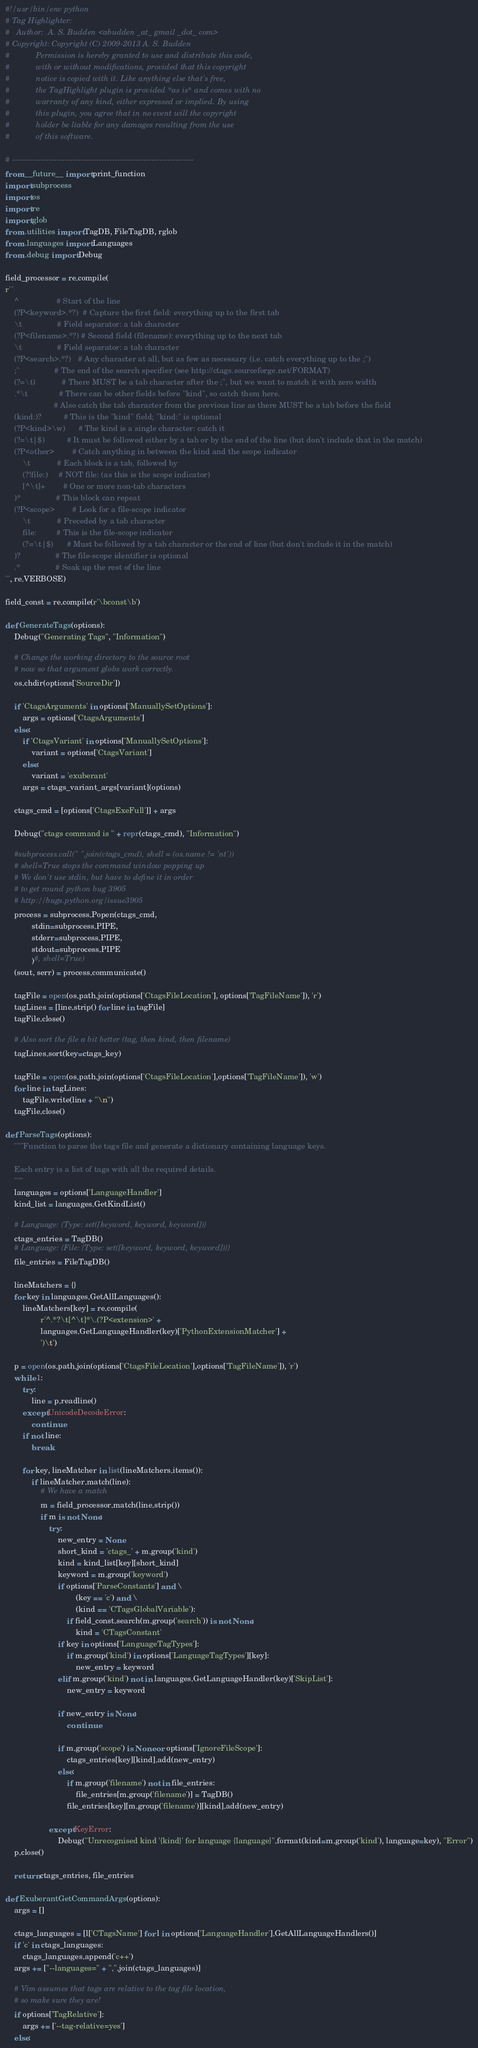<code> <loc_0><loc_0><loc_500><loc_500><_Python_>#!/usr/bin/env python
# Tag Highlighter:
#   Author:  A. S. Budden <abudden _at_ gmail _dot_ com>
# Copyright: Copyright (C) 2009-2013 A. S. Budden
#            Permission is hereby granted to use and distribute this code,
#            with or without modifications, provided that this copyright
#            notice is copied with it. Like anything else that's free,
#            the TagHighlight plugin is provided *as is* and comes with no
#            warranty of any kind, either expressed or implied. By using
#            this plugin, you agree that in no event will the copyright
#            holder be liable for any damages resulting from the use
#            of this software.

# ---------------------------------------------------------------------
from __future__ import print_function
import subprocess
import os
import re
import glob
from .utilities import TagDB, FileTagDB, rglob
from .languages import Languages
from .debug import Debug

field_processor = re.compile(
r'''
    ^                 # Start of the line
    (?P<keyword>.*?)  # Capture the first field: everything up to the first tab
    \t                # Field separator: a tab character
    (?P<filename>.*?) # Second field (filename): everything up to the next tab
    \t                # Field separator: a tab character
    (?P<search>.*?)   # Any character at all, but as few as necessary (i.e. catch everything up to the ;")
    ;"                # The end of the search specifier (see http://ctags.sourceforge.net/FORMAT)
    (?=\t)            # There MUST be a tab character after the ;", but we want to match it with zero width
    .*\t              # There can be other fields before "kind", so catch them here.
                      # Also catch the tab character from the previous line as there MUST be a tab before the field
    (kind:)?          # This is the "kind" field; "kind:" is optional
    (?P<kind>\w)      # The kind is a single character: catch it
    (?=\t|$)          # It must be followed either by a tab or by the end of the line (but don't include that in the match)
    (?P<other>        # Catch anything in between the kind and the scope indicator
        \t            # Each block is a tab, followed by
        (?!file:)     # NOT file: (as this is the scope indicator)
        [^\t]+        # One or more non-tab characters
    )*                # This block can repeat
    (?P<scope>        # Look for a file-scope indicator
        \t            # Preceded by a tab character
        file:         # This is the file-scope indicator
        (?=\t|$)      # Must be followed by a tab character or the end of line (but don't include it in the match)
    )?                # The file-scope identifier is optional
    .*                # Soak up the rest of the line
''', re.VERBOSE)

field_const = re.compile(r'\bconst\b')

def GenerateTags(options):
    Debug("Generating Tags", "Information")

    # Change the working directory to the source root
    # now so that argument globs work correctly.
    os.chdir(options['SourceDir'])

    if 'CtagsArguments' in options['ManuallySetOptions']:
        args = options['CtagsArguments']
    else:
        if 'CtagsVariant' in options['ManuallySetOptions']:
            variant = options['CtagsVariant']
        else:
            variant = 'exuberant'
        args = ctags_variant_args[variant](options)

    ctags_cmd = [options['CtagsExeFull']] + args

    Debug("ctags command is " + repr(ctags_cmd), "Information")

    #subprocess.call(" ".join(ctags_cmd), shell = (os.name != 'nt'))
    # shell=True stops the command window popping up
    # We don't use stdin, but have to define it in order
    # to get round python bug 3905
    # http://bugs.python.org/issue3905
    process = subprocess.Popen(ctags_cmd,
            stdin=subprocess.PIPE,
            stderr=subprocess.PIPE,
            stdout=subprocess.PIPE
            )#, shell=True)
    (sout, serr) = process.communicate()

    tagFile = open(os.path.join(options['CtagsFileLocation'], options['TagFileName']), 'r')
    tagLines = [line.strip() for line in tagFile]
    tagFile.close()

    # Also sort the file a bit better (tag, then kind, then filename)
    tagLines.sort(key=ctags_key)

    tagFile = open(os.path.join(options['CtagsFileLocation'],options['TagFileName']), 'w')
    for line in tagLines:
        tagFile.write(line + "\n")
    tagFile.close()

def ParseTags(options):
    """Function to parse the tags file and generate a dictionary containing language keys.

    Each entry is a list of tags with all the required details.
    """
    languages = options['LanguageHandler']
    kind_list = languages.GetKindList()

    # Language: {Type: set([keyword, keyword, keyword])}
    ctags_entries = TagDB()
    # Language: {File: {Type: set([keyword, keyword, keyword])}}
    file_entries = FileTagDB()

    lineMatchers = {}
    for key in languages.GetAllLanguages():
        lineMatchers[key] = re.compile(
                r'^.*?\t[^\t]*\.(?P<extension>' +
                languages.GetLanguageHandler(key)['PythonExtensionMatcher'] +
                ')\t')

    p = open(os.path.join(options['CtagsFileLocation'],options['TagFileName']), 'r')
    while 1:
        try:
            line = p.readline()
        except UnicodeDecodeError:
            continue
        if not line:
            break

        for key, lineMatcher in list(lineMatchers.items()):
            if lineMatcher.match(line):
                # We have a match
                m = field_processor.match(line.strip())
                if m is not None:
                    try:
                        new_entry = None
                        short_kind = 'ctags_' + m.group('kind')
                        kind = kind_list[key][short_kind]
                        keyword = m.group('keyword')
                        if options['ParseConstants'] and \
                                (key == 'c') and \
                                (kind == 'CTagsGlobalVariable'):
                            if field_const.search(m.group('search')) is not None:
                                kind = 'CTagsConstant'
                        if key in options['LanguageTagTypes']:
                            if m.group('kind') in options['LanguageTagTypes'][key]:
                                new_entry = keyword
                        elif m.group('kind') not in languages.GetLanguageHandler(key)['SkipList']:
                            new_entry = keyword

                        if new_entry is None:
                            continue

                        if m.group('scope') is None or options['IgnoreFileScope']:
                            ctags_entries[key][kind].add(new_entry)
                        else:
                            if m.group('filename') not in file_entries:
                                file_entries[m.group('filename')] = TagDB()
                            file_entries[key][m.group('filename')][kind].add(new_entry)

                    except KeyError:
                        Debug("Unrecognised kind '{kind}' for language {language}".format(kind=m.group('kind'), language=key), "Error")
    p.close()

    return ctags_entries, file_entries

def ExuberantGetCommandArgs(options):
    args = []

    ctags_languages = [l['CTagsName'] for l in options['LanguageHandler'].GetAllLanguageHandlers()]
    if 'c' in ctags_languages:
        ctags_languages.append('c++')
    args += ["--languages=" + ",".join(ctags_languages)]

    # Vim assumes that tags are relative to the tag file location,
    # so make sure they are!
    if options['TagRelative']:
        args += ['--tag-relative=yes']
    else:</code> 